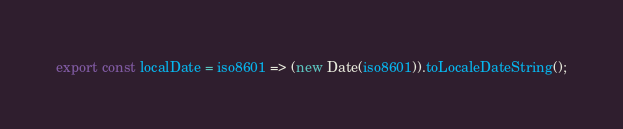Convert code to text. <code><loc_0><loc_0><loc_500><loc_500><_JavaScript_>export const localDate = iso8601 => (new Date(iso8601)).toLocaleDateString();
</code> 